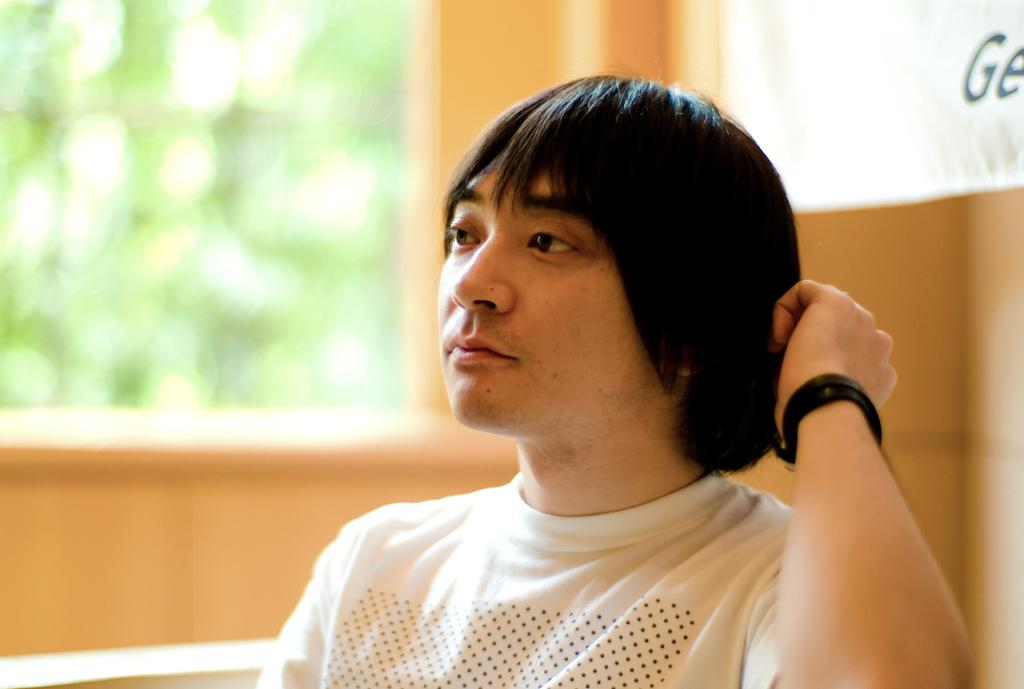What is the main subject of the image? There is a person sitting in the image. What can be seen in the background of the image? There is a cloth and a window in the background of the image. What type of crime is being committed in the image? There is: There is no crime being committed in the image; it simply shows a person sitting with a cloth and a window in the background. How many books are visible in the image? There are no books present in the image. 